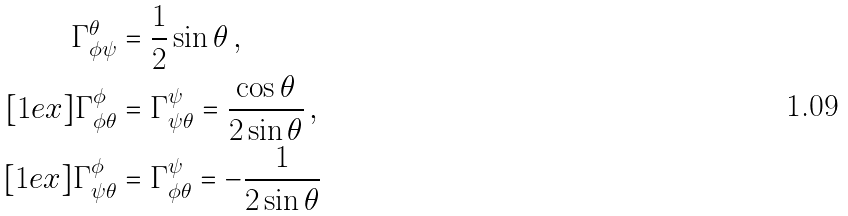Convert formula to latex. <formula><loc_0><loc_0><loc_500><loc_500>\Gamma ^ { \theta } _ { \phi \psi } & = \frac { 1 } { 2 } \sin \theta \, , \\ [ 1 e x ] \Gamma ^ { \phi } _ { \phi \theta } & = \Gamma ^ { \psi } _ { \psi \theta } = \frac { \cos \theta } { 2 \sin \theta } \, , \\ [ 1 e x ] \Gamma ^ { \phi } _ { \psi \theta } & = \Gamma ^ { \psi } _ { \phi \theta } = - \frac { 1 } { 2 \sin \theta }</formula> 